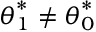Convert formula to latex. <formula><loc_0><loc_0><loc_500><loc_500>{ \theta } _ { 1 } ^ { * } \neq { \theta } _ { 0 } ^ { * }</formula> 